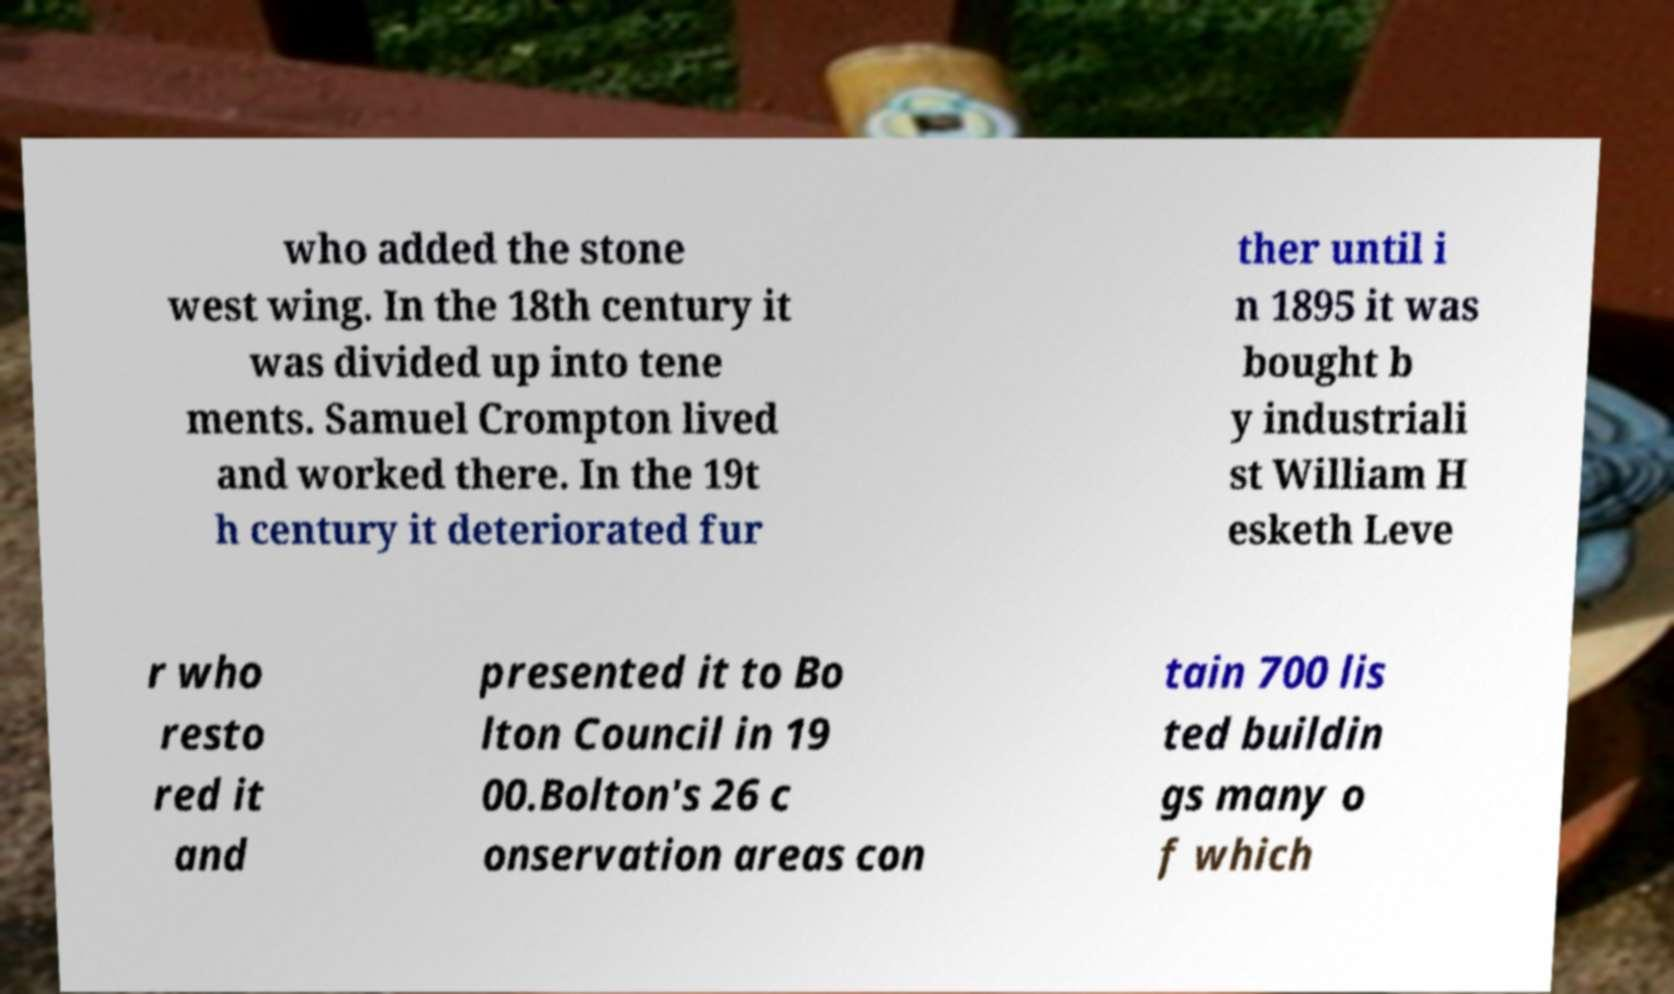Can you accurately transcribe the text from the provided image for me? who added the stone west wing. In the 18th century it was divided up into tene ments. Samuel Crompton lived and worked there. In the 19t h century it deteriorated fur ther until i n 1895 it was bought b y industriali st William H esketh Leve r who resto red it and presented it to Bo lton Council in 19 00.Bolton's 26 c onservation areas con tain 700 lis ted buildin gs many o f which 